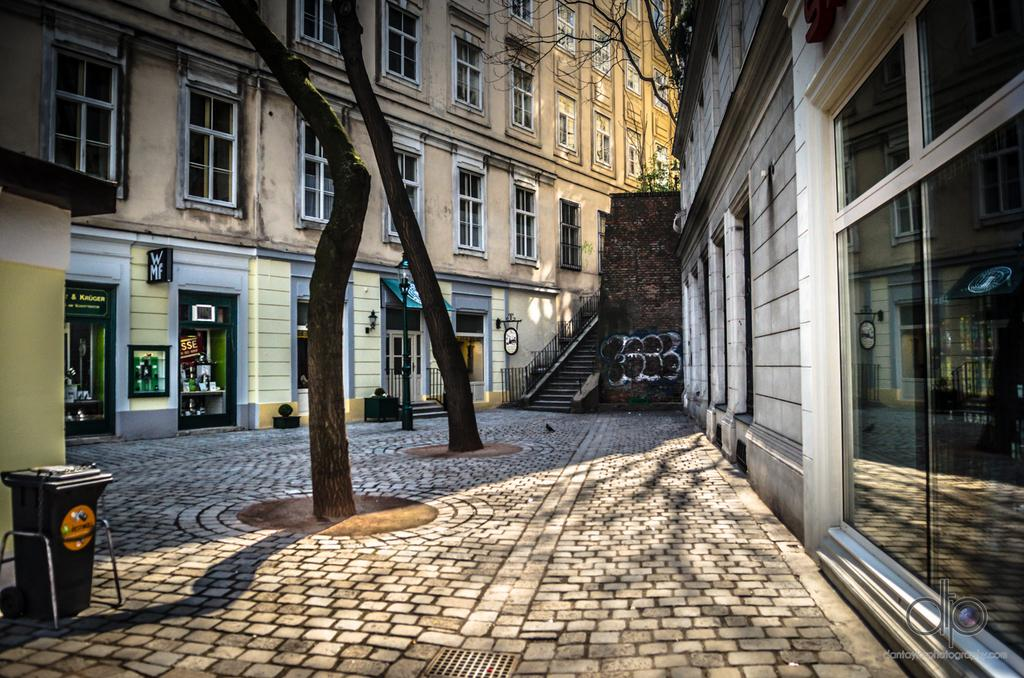What type of structures can be seen in the image? There are buildings in the image. What natural elements are present in the image? There are trees in the image. What object is used for waste disposal in the image? There is a dustbin in the image. What type of signage is present in the image? There are boards with text in the image. How many giants can be seen interacting with the buildings in the image? There are no giants present in the image. Who is the owner of the trees in the image? The image does not provide information about the ownership of the trees. 